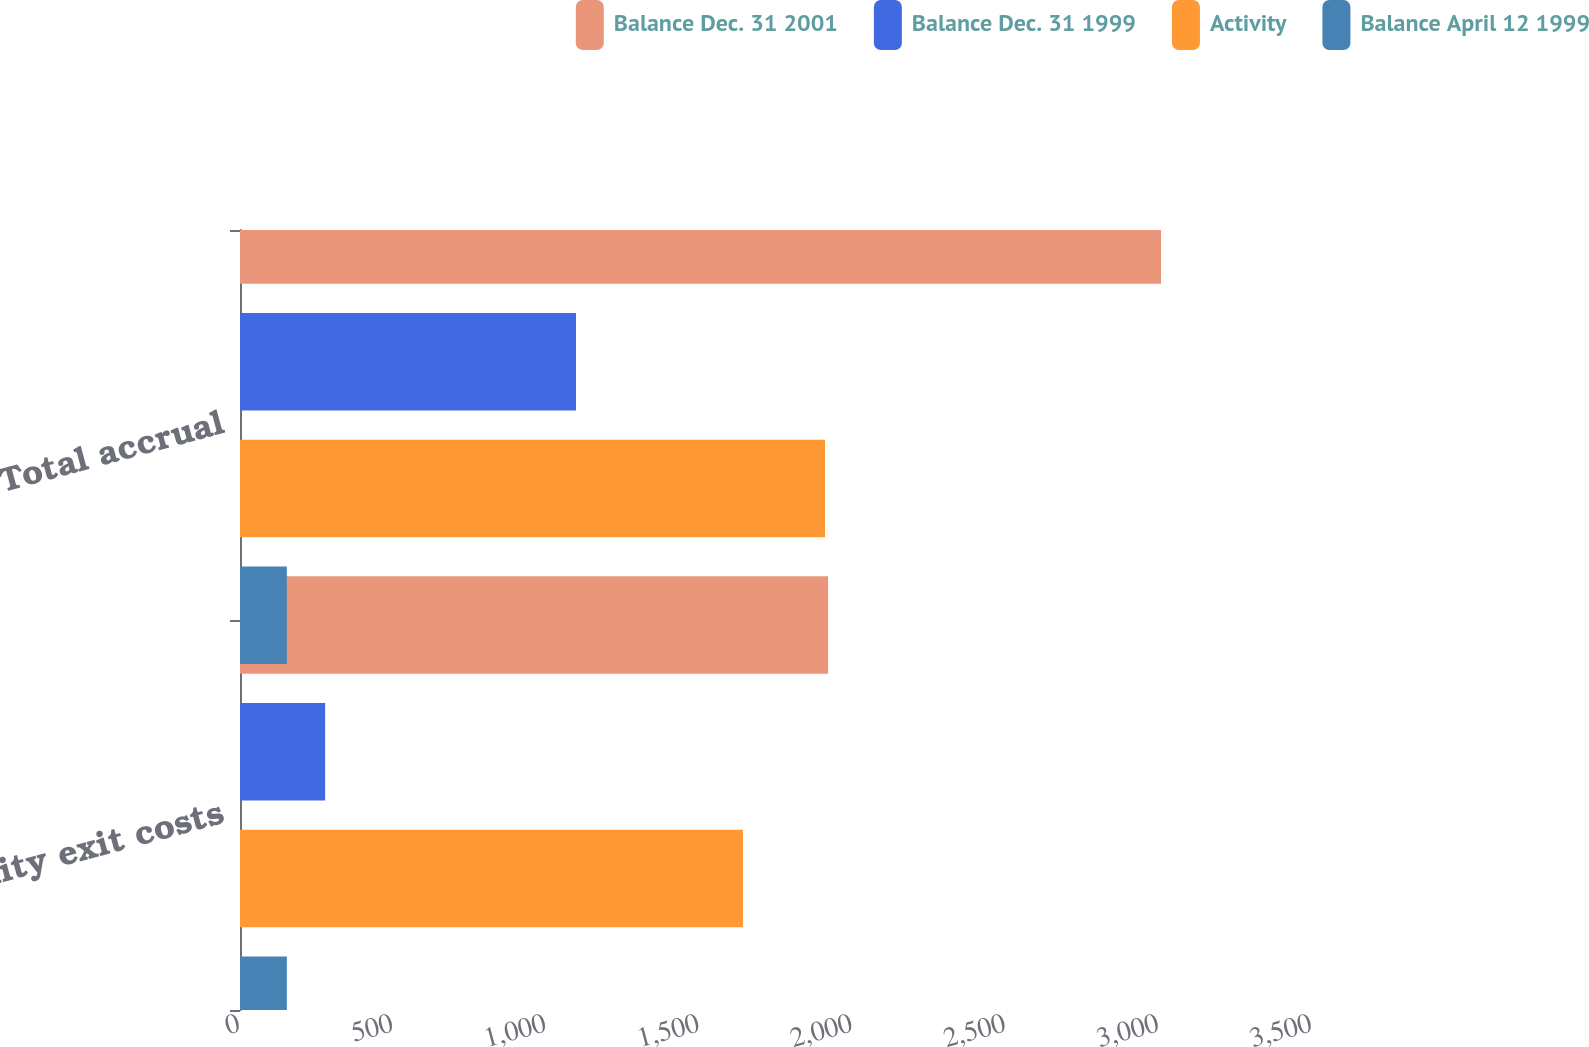Convert chart. <chart><loc_0><loc_0><loc_500><loc_500><stacked_bar_chart><ecel><fcel>Facility exit costs<fcel>Total accrual<nl><fcel>Balance Dec. 31 2001<fcel>1920<fcel>3007<nl><fcel>Balance Dec. 31 1999<fcel>278<fcel>1097<nl><fcel>Activity<fcel>1642<fcel>1910<nl><fcel>Balance April 12 1999<fcel>153<fcel>153<nl></chart> 